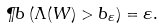<formula> <loc_0><loc_0><loc_500><loc_500>\P b \left ( \Lambda ( W ) > b _ { \varepsilon } \right ) = \varepsilon .</formula> 